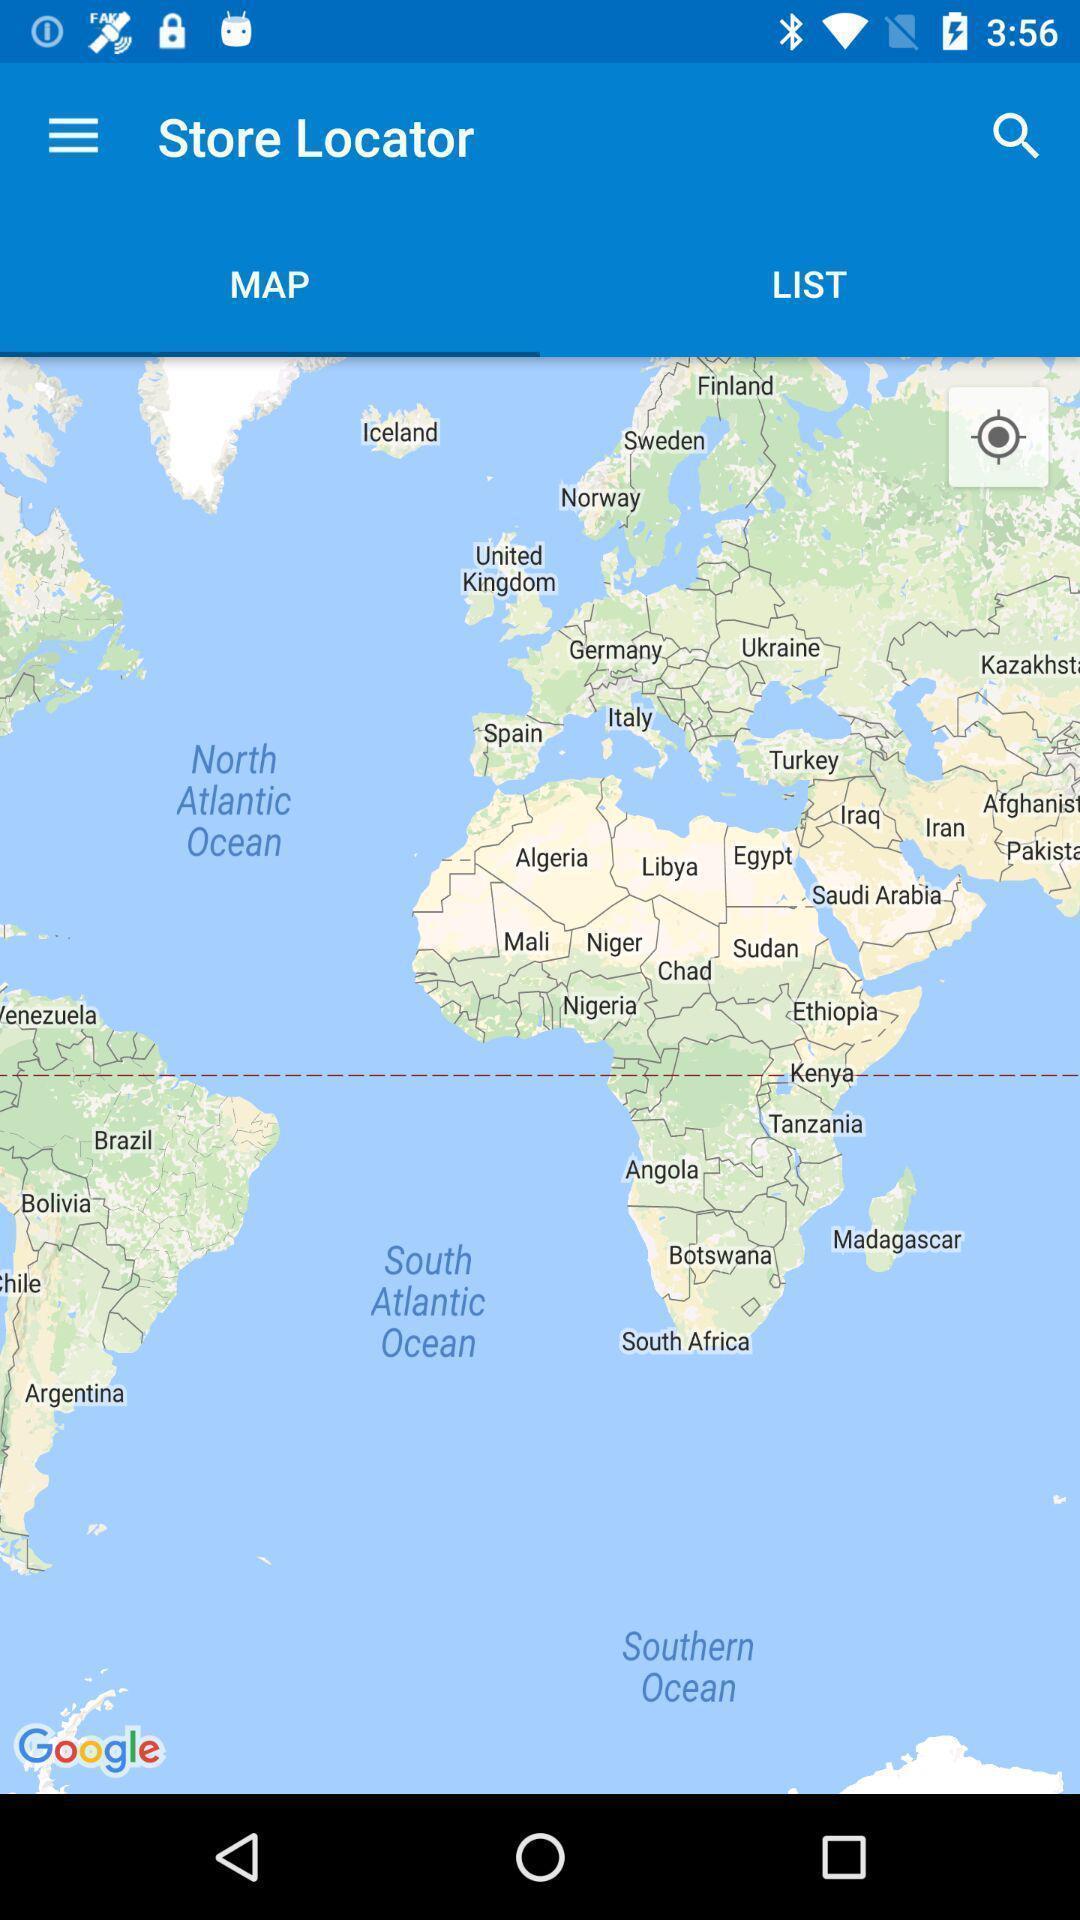Summarize the information in this screenshot. Screen shows map view in a navigation app. 